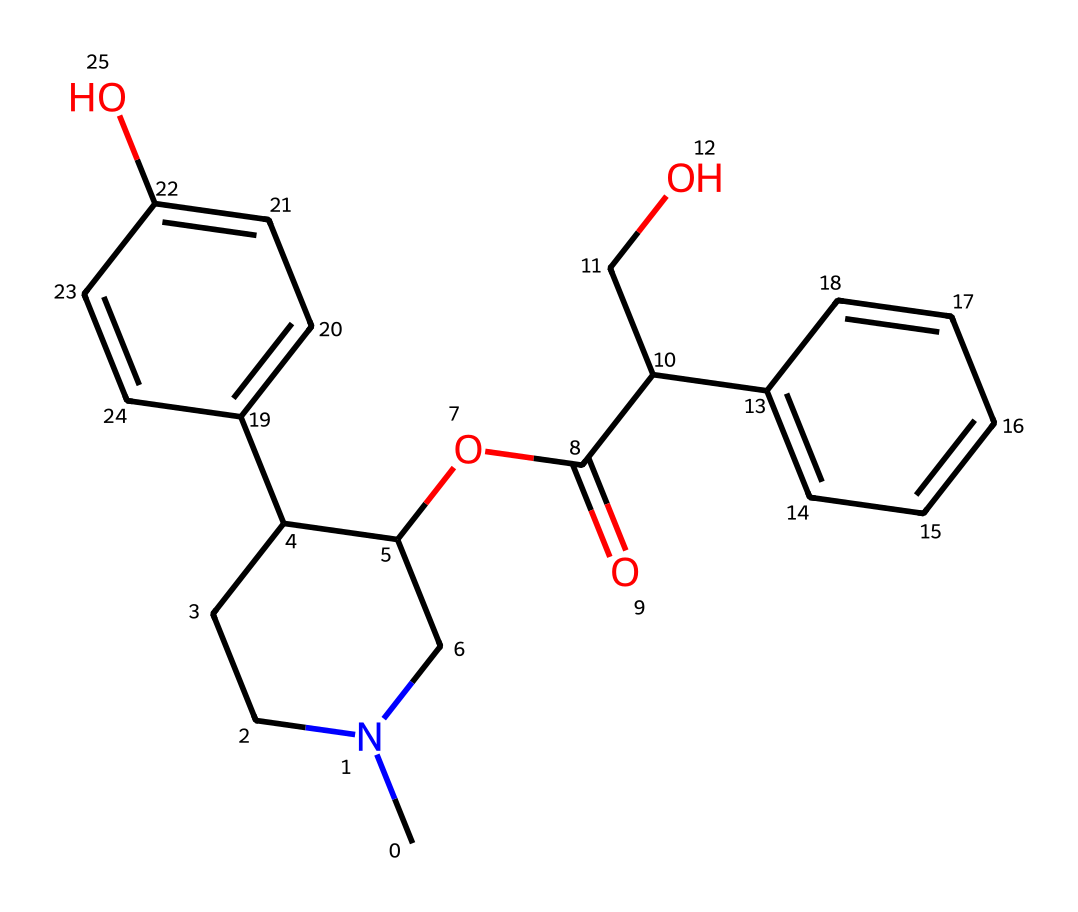How many rings are present in the structure of atropine? The SMILES representation reveals that there are two distinct rings present; one is a five-membered ring and the other is a six-membered ring. This can be identified by the numbered atoms within the structure.
Answer: two What functional groups can be identified in the structure of atropine? By analyzing the structural components, we can identify a phenol group due to the hydroxyl (-OH) attached to a benzene ring, and an ester functional group from the carbonyl (C=O) and the oxygen linkage (C-O).
Answer: phenol and ester What is the total number of carbon atoms in the atropine structure? Counting all the carbon atoms encoded in the SMILES string, we can determine that there are 22 carbon atoms present in total, as all carbon notations start with “C.”
Answer: 22 How does the presence of nitrogen influence the characteristics of atropine? The nitrogen atom is crucial in forming the basicity and biological activity associated with alkaloids; it contributes to the overall structural stability and signaling properties of the compound.
Answer: basicity Which part of the atropine structure indicates its classification as an alkaloid? The presence of a nitrogen atom within the structure is the definitive characteristic that classifies this compound as an alkaloid, as they are primarily characterized by the incorporation of nitrogen.
Answer: nitrogen atom What type of isomerism can atropine exhibit based on its structure? Due to the presence of multiple chiral centers in the structure, atropine can exhibit stereoisomerism, specifically enantiomerism, which is typical for compounds with chiral centers.
Answer: stereoisomerism What is the approximate molecular weight of atropine? By calculating from the individual atomic weights of all elements present in the SMILES, we can approximate the molecular weight of atropine to be around 303.4 g/mol.
Answer: 303.4 g/mol 